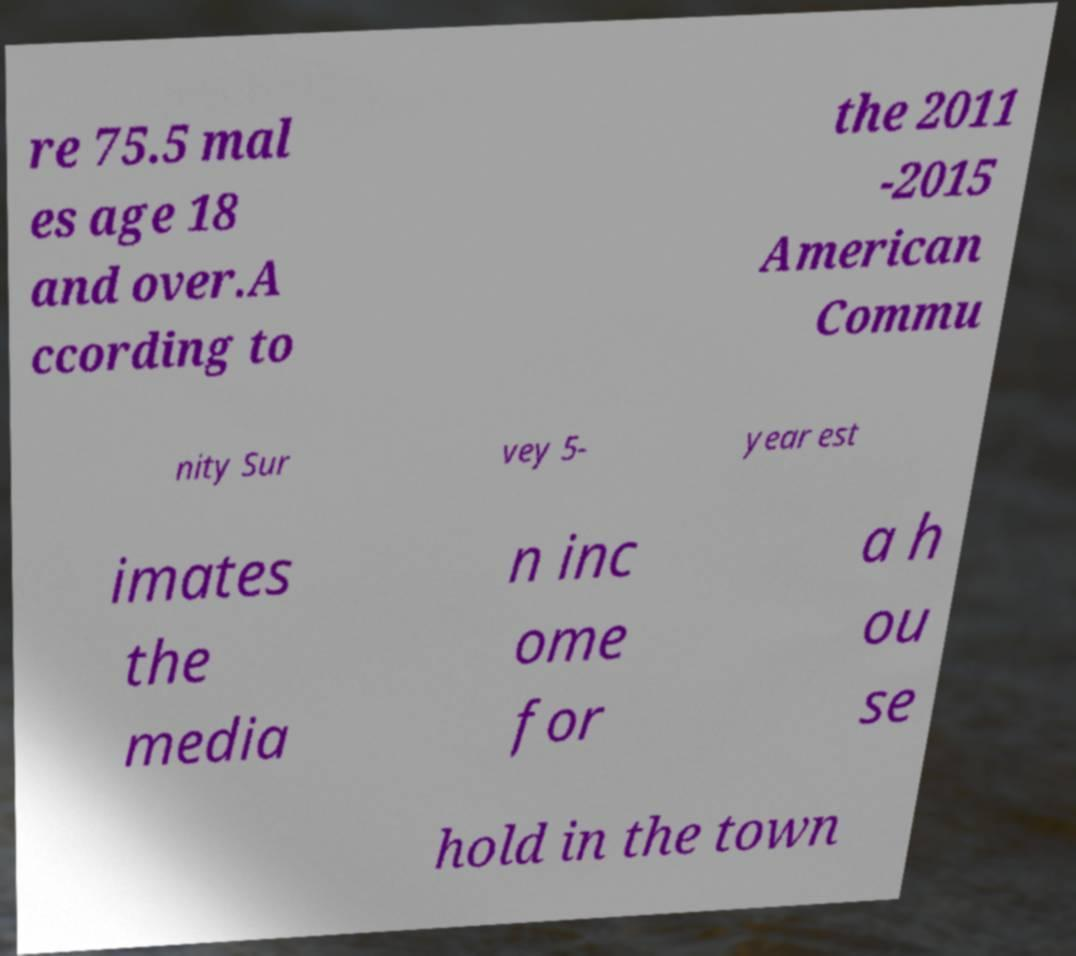What messages or text are displayed in this image? I need them in a readable, typed format. re 75.5 mal es age 18 and over.A ccording to the 2011 -2015 American Commu nity Sur vey 5- year est imates the media n inc ome for a h ou se hold in the town 